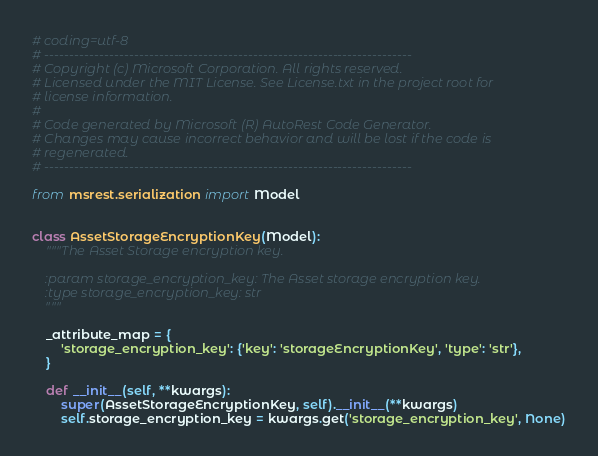Convert code to text. <code><loc_0><loc_0><loc_500><loc_500><_Python_># coding=utf-8
# --------------------------------------------------------------------------
# Copyright (c) Microsoft Corporation. All rights reserved.
# Licensed under the MIT License. See License.txt in the project root for
# license information.
#
# Code generated by Microsoft (R) AutoRest Code Generator.
# Changes may cause incorrect behavior and will be lost if the code is
# regenerated.
# --------------------------------------------------------------------------

from msrest.serialization import Model


class AssetStorageEncryptionKey(Model):
    """The Asset Storage encryption key.

    :param storage_encryption_key: The Asset storage encryption key.
    :type storage_encryption_key: str
    """

    _attribute_map = {
        'storage_encryption_key': {'key': 'storageEncryptionKey', 'type': 'str'},
    }

    def __init__(self, **kwargs):
        super(AssetStorageEncryptionKey, self).__init__(**kwargs)
        self.storage_encryption_key = kwargs.get('storage_encryption_key', None)
</code> 